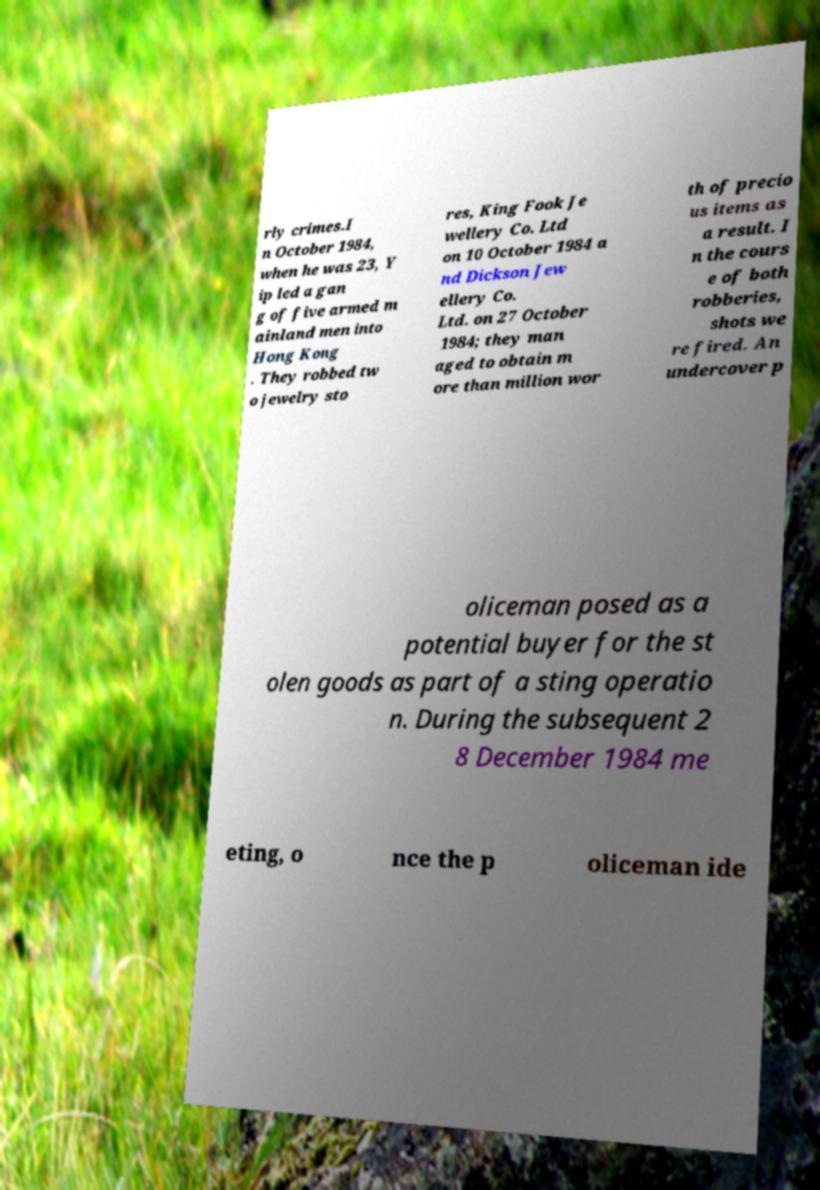Can you read and provide the text displayed in the image?This photo seems to have some interesting text. Can you extract and type it out for me? rly crimes.I n October 1984, when he was 23, Y ip led a gan g of five armed m ainland men into Hong Kong . They robbed tw o jewelry sto res, King Fook Je wellery Co. Ltd on 10 October 1984 a nd Dickson Jew ellery Co. Ltd. on 27 October 1984; they man aged to obtain m ore than million wor th of precio us items as a result. I n the cours e of both robberies, shots we re fired. An undercover p oliceman posed as a potential buyer for the st olen goods as part of a sting operatio n. During the subsequent 2 8 December 1984 me eting, o nce the p oliceman ide 